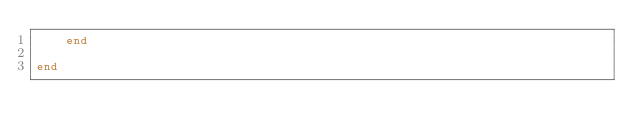Convert code to text. <code><loc_0><loc_0><loc_500><loc_500><_Ruby_>	end

end
</code> 